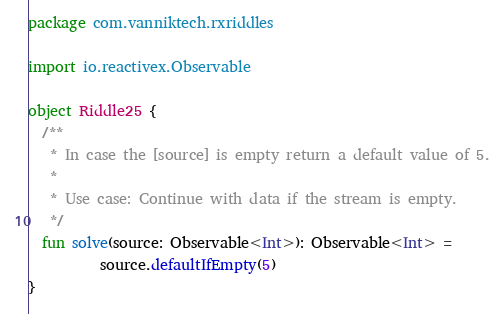Convert code to text. <code><loc_0><loc_0><loc_500><loc_500><_Kotlin_>package com.vanniktech.rxriddles

import io.reactivex.Observable

object Riddle25 {
  /**
   * In case the [source] is empty return a default value of 5.
   *
   * Use case: Continue with data if the stream is empty.
   */
  fun solve(source: Observable<Int>): Observable<Int> =
          source.defaultIfEmpty(5)
}
</code> 